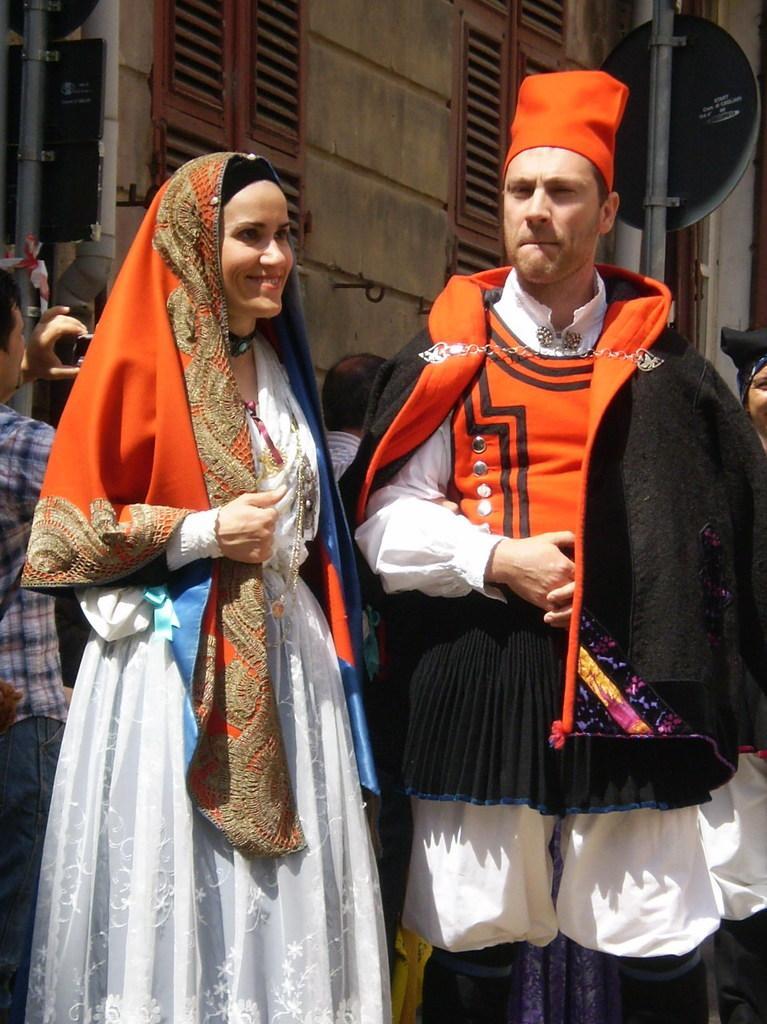Please provide a concise description of this image. A man and a woman are standing. In the background there are few persons,window doors,wall,boards on the poles and a man on the left side is holding an object in his hands. 